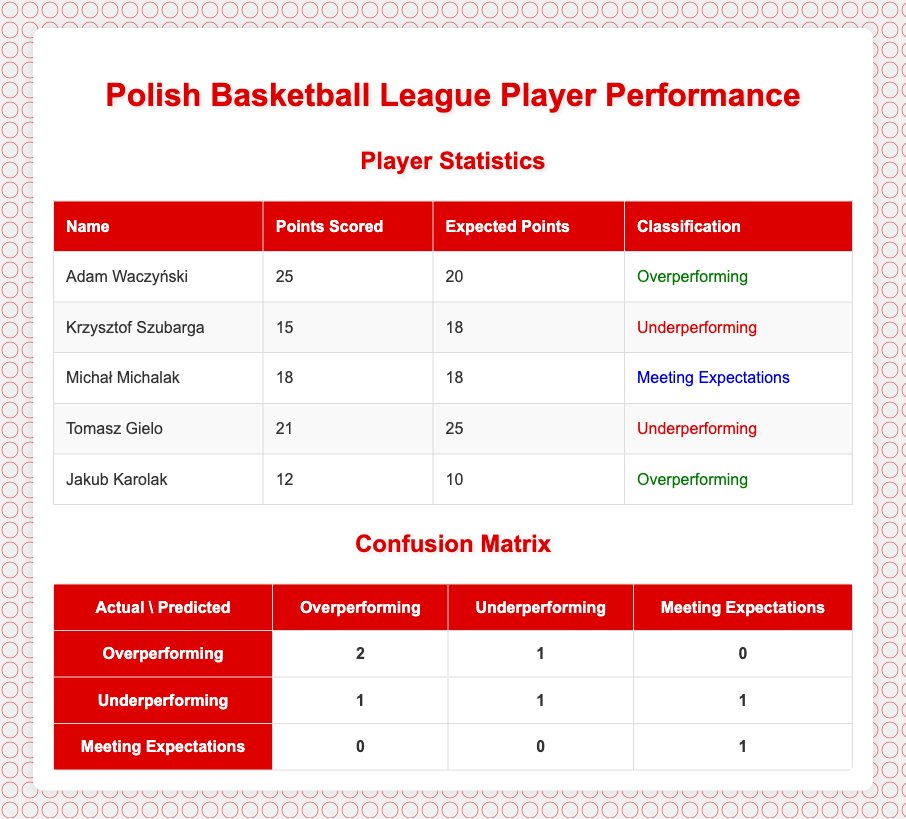What is the total number of players who overperformed? There are two players classified as overperforming: Adam Waczyński and Jakub Karolak.
Answer: 2 How many players are classified as underperforming? There are two players classified as underperforming: Krzysztof Szubarga and Tomasz Gielo.
Answer: 2 What percentage of players met their expectations? There is one player classified as meeting expectations (Michał Michalak) out of a total of five players. The percentage is (1/5) * 100 = 20%.
Answer: 20% Did any player score exactly their expected points? Yes, Michał Michalak scored exactly his expected points of 18.
Answer: Yes Which classification received the highest number of correct predictions? The Overperforming classification had the highest number of correct predictions, with 2 players correctly predicted as overperforming.
Answer: Overperforming How many total players were misclassified in the Underperforming category? In the Underperforming actual category, 1 player was misclassified as Overperforming, 1 player was correctly classified, and 1 player was misclassified as Meeting Expectations. That totals to 2 misclassifications.
Answer: 2 What is the sum of points scored by all players classified as underperforming? Krzysztof Szubarga scored 15 points and Tomasz Gielo scored 21 points. The total is 15 + 21 = 36 points scored.
Answer: 36 If a player overperforms, how many times were they incorrectly predicted as underperforming? Out of the classification, 1 player who overperformed was incorrectly predicted as underperforming.
Answer: 1 In the confusion matrix, what is the total number of players predicted as meeting expectations? In the confusion matrix, there is only 1 player predicted as meeting expectations (from the actual Meeting Expectations classification).
Answer: 1 